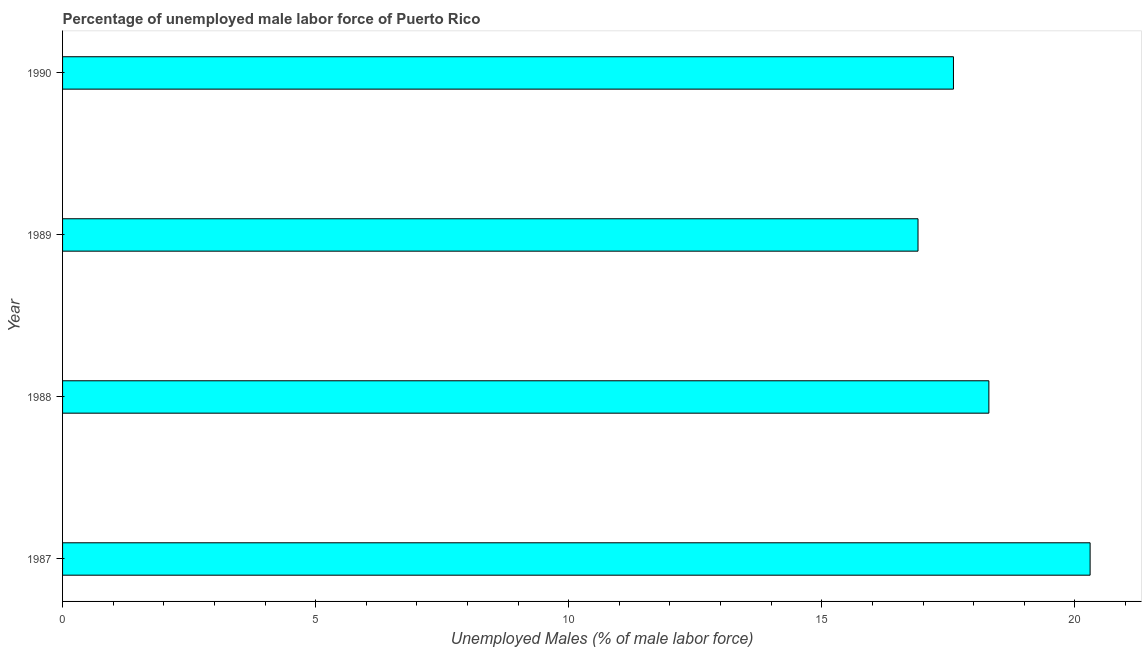Does the graph contain grids?
Provide a short and direct response. No. What is the title of the graph?
Offer a very short reply. Percentage of unemployed male labor force of Puerto Rico. What is the label or title of the X-axis?
Provide a succinct answer. Unemployed Males (% of male labor force). What is the total unemployed male labour force in 1987?
Your response must be concise. 20.3. Across all years, what is the maximum total unemployed male labour force?
Your answer should be compact. 20.3. Across all years, what is the minimum total unemployed male labour force?
Your answer should be compact. 16.9. In which year was the total unemployed male labour force maximum?
Your response must be concise. 1987. What is the sum of the total unemployed male labour force?
Give a very brief answer. 73.1. What is the difference between the total unemployed male labour force in 1987 and 1990?
Offer a terse response. 2.7. What is the average total unemployed male labour force per year?
Offer a very short reply. 18.27. What is the median total unemployed male labour force?
Provide a short and direct response. 17.95. Is the total unemployed male labour force in 1988 less than that in 1989?
Offer a very short reply. No. Is the difference between the total unemployed male labour force in 1988 and 1990 greater than the difference between any two years?
Offer a very short reply. No. What is the difference between the highest and the lowest total unemployed male labour force?
Your answer should be compact. 3.4. In how many years, is the total unemployed male labour force greater than the average total unemployed male labour force taken over all years?
Give a very brief answer. 2. Are all the bars in the graph horizontal?
Offer a terse response. Yes. How many years are there in the graph?
Ensure brevity in your answer.  4. What is the difference between two consecutive major ticks on the X-axis?
Offer a very short reply. 5. Are the values on the major ticks of X-axis written in scientific E-notation?
Ensure brevity in your answer.  No. What is the Unemployed Males (% of male labor force) of 1987?
Ensure brevity in your answer.  20.3. What is the Unemployed Males (% of male labor force) of 1988?
Ensure brevity in your answer.  18.3. What is the Unemployed Males (% of male labor force) of 1989?
Keep it short and to the point. 16.9. What is the Unemployed Males (% of male labor force) in 1990?
Ensure brevity in your answer.  17.6. What is the difference between the Unemployed Males (% of male labor force) in 1987 and 1988?
Provide a short and direct response. 2. What is the difference between the Unemployed Males (% of male labor force) in 1988 and 1989?
Provide a short and direct response. 1.4. What is the difference between the Unemployed Males (% of male labor force) in 1988 and 1990?
Make the answer very short. 0.7. What is the ratio of the Unemployed Males (% of male labor force) in 1987 to that in 1988?
Your answer should be very brief. 1.11. What is the ratio of the Unemployed Males (% of male labor force) in 1987 to that in 1989?
Provide a short and direct response. 1.2. What is the ratio of the Unemployed Males (% of male labor force) in 1987 to that in 1990?
Provide a succinct answer. 1.15. What is the ratio of the Unemployed Males (% of male labor force) in 1988 to that in 1989?
Your answer should be compact. 1.08. What is the ratio of the Unemployed Males (% of male labor force) in 1989 to that in 1990?
Offer a terse response. 0.96. 